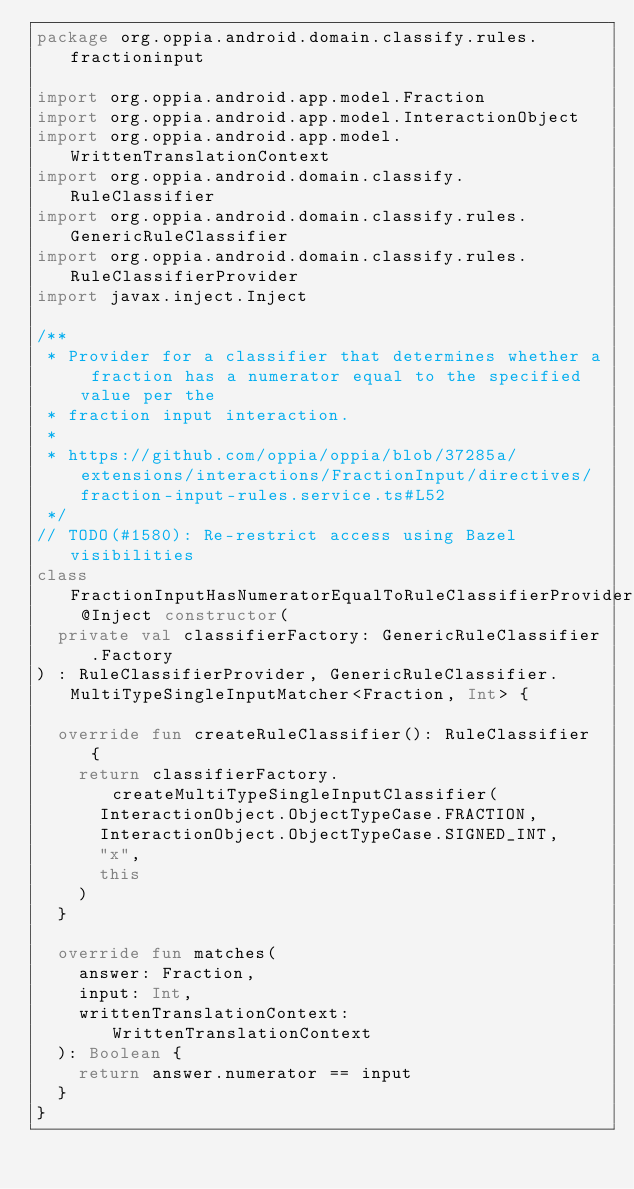<code> <loc_0><loc_0><loc_500><loc_500><_Kotlin_>package org.oppia.android.domain.classify.rules.fractioninput

import org.oppia.android.app.model.Fraction
import org.oppia.android.app.model.InteractionObject
import org.oppia.android.app.model.WrittenTranslationContext
import org.oppia.android.domain.classify.RuleClassifier
import org.oppia.android.domain.classify.rules.GenericRuleClassifier
import org.oppia.android.domain.classify.rules.RuleClassifierProvider
import javax.inject.Inject

/**
 * Provider for a classifier that determines whether a fraction has a numerator equal to the specified value per the
 * fraction input interaction.
 *
 * https://github.com/oppia/oppia/blob/37285a/extensions/interactions/FractionInput/directives/fraction-input-rules.service.ts#L52
 */
// TODO(#1580): Re-restrict access using Bazel visibilities
class FractionInputHasNumeratorEqualToRuleClassifierProvider @Inject constructor(
  private val classifierFactory: GenericRuleClassifier.Factory
) : RuleClassifierProvider, GenericRuleClassifier.MultiTypeSingleInputMatcher<Fraction, Int> {

  override fun createRuleClassifier(): RuleClassifier {
    return classifierFactory.createMultiTypeSingleInputClassifier(
      InteractionObject.ObjectTypeCase.FRACTION,
      InteractionObject.ObjectTypeCase.SIGNED_INT,
      "x",
      this
    )
  }

  override fun matches(
    answer: Fraction,
    input: Int,
    writtenTranslationContext: WrittenTranslationContext
  ): Boolean {
    return answer.numerator == input
  }
}
</code> 